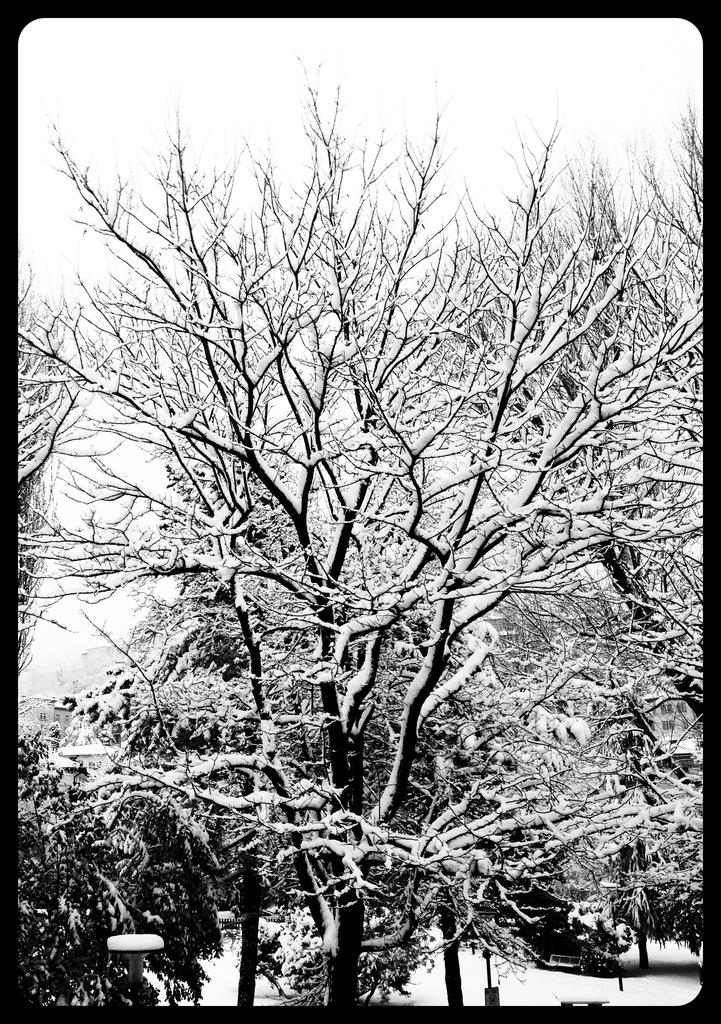What is the color scheme of the image? The image is black and white. What type of natural elements can be seen in the image? There are trees in the image. What is the condition of the trees in the image? The trees are covered with snow. Can you see a deer using a hammer to level the snow in the image? No, there is no deer or hammer present in the image. The image only features trees covered with snow. 